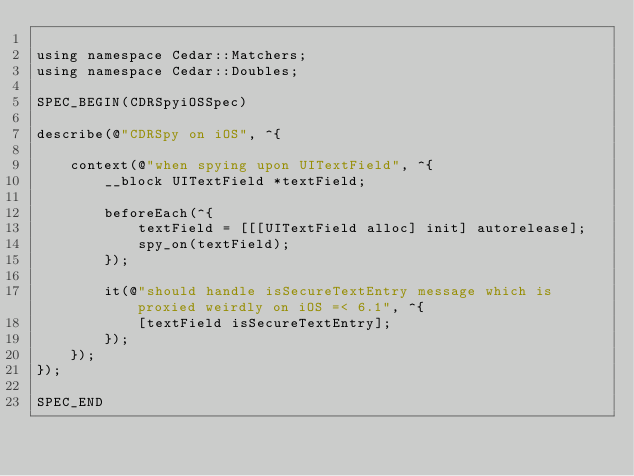Convert code to text. <code><loc_0><loc_0><loc_500><loc_500><_ObjectiveC_>
using namespace Cedar::Matchers;
using namespace Cedar::Doubles;

SPEC_BEGIN(CDRSpyiOSSpec)

describe(@"CDRSpy on iOS", ^{

    context(@"when spying upon UITextField", ^{
        __block UITextField *textField;

        beforeEach(^{
            textField = [[[UITextField alloc] init] autorelease];
            spy_on(textField);
        });

        it(@"should handle isSecureTextEntry message which is proxied weirdly on iOS =< 6.1", ^{
            [textField isSecureTextEntry];
        });
    });
});

SPEC_END
</code> 